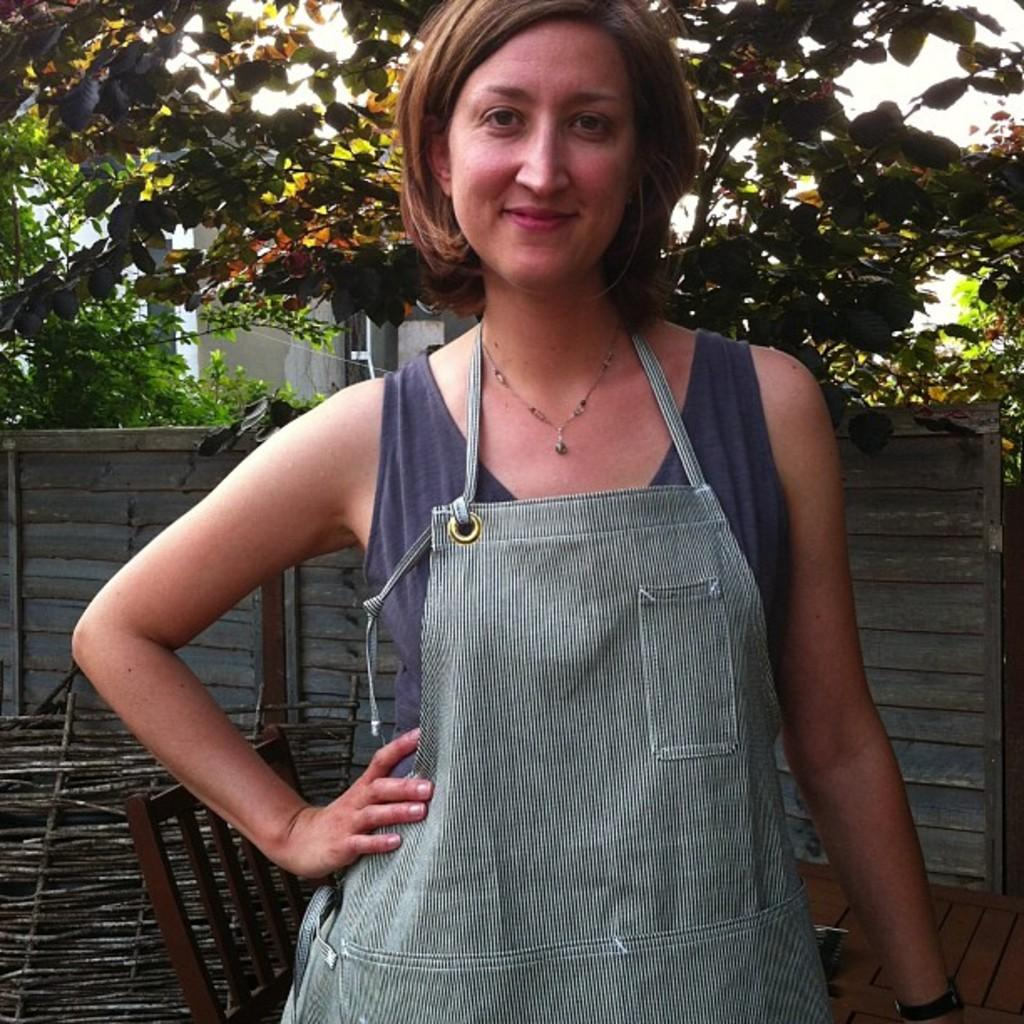Who is present in the image? There is a woman in the image. What is the woman doing in the image? The woman is standing and smiling. What can be seen in the background of the image? There is a fence, trees, and a chair in the background of the image. What type of grass is being used as linen in the image? There is no grass or linen present in the image. How many yards of fabric are visible in the image? There is no fabric or yard measurement mentioned in the image. 